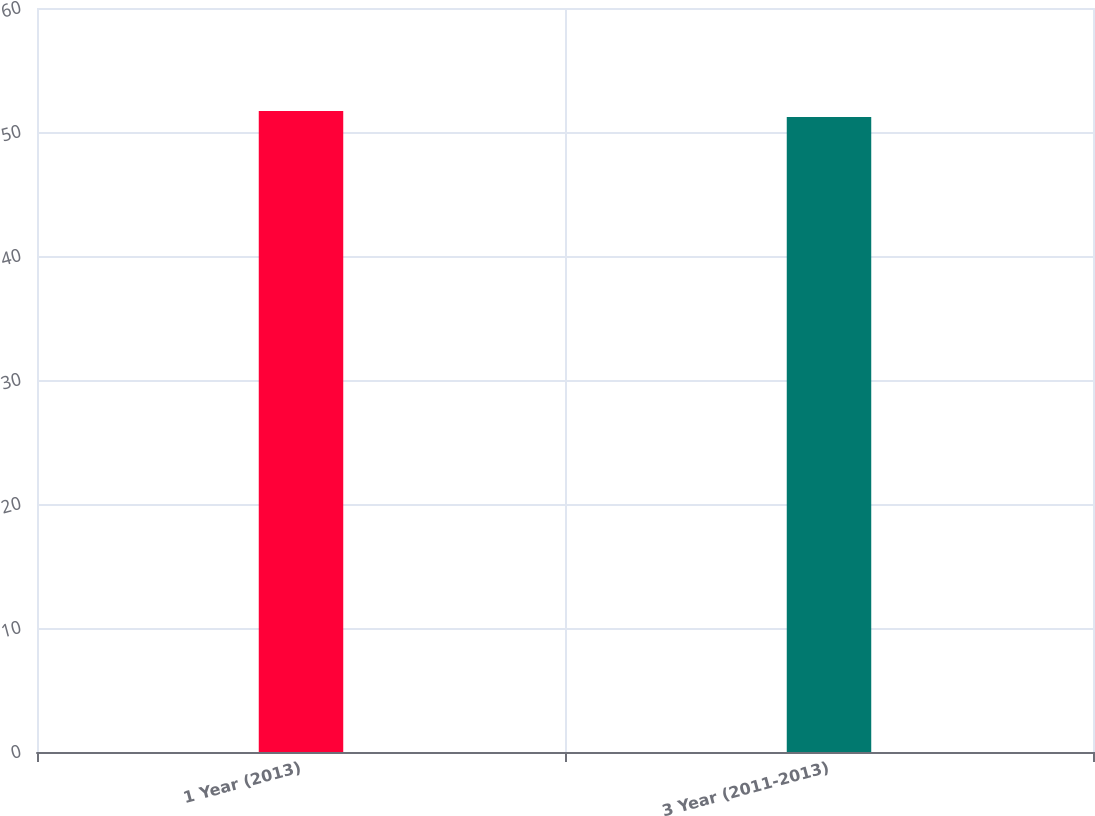Convert chart to OTSL. <chart><loc_0><loc_0><loc_500><loc_500><bar_chart><fcel>1 Year (2013)<fcel>3 Year (2011-2013)<nl><fcel>51.7<fcel>51.2<nl></chart> 